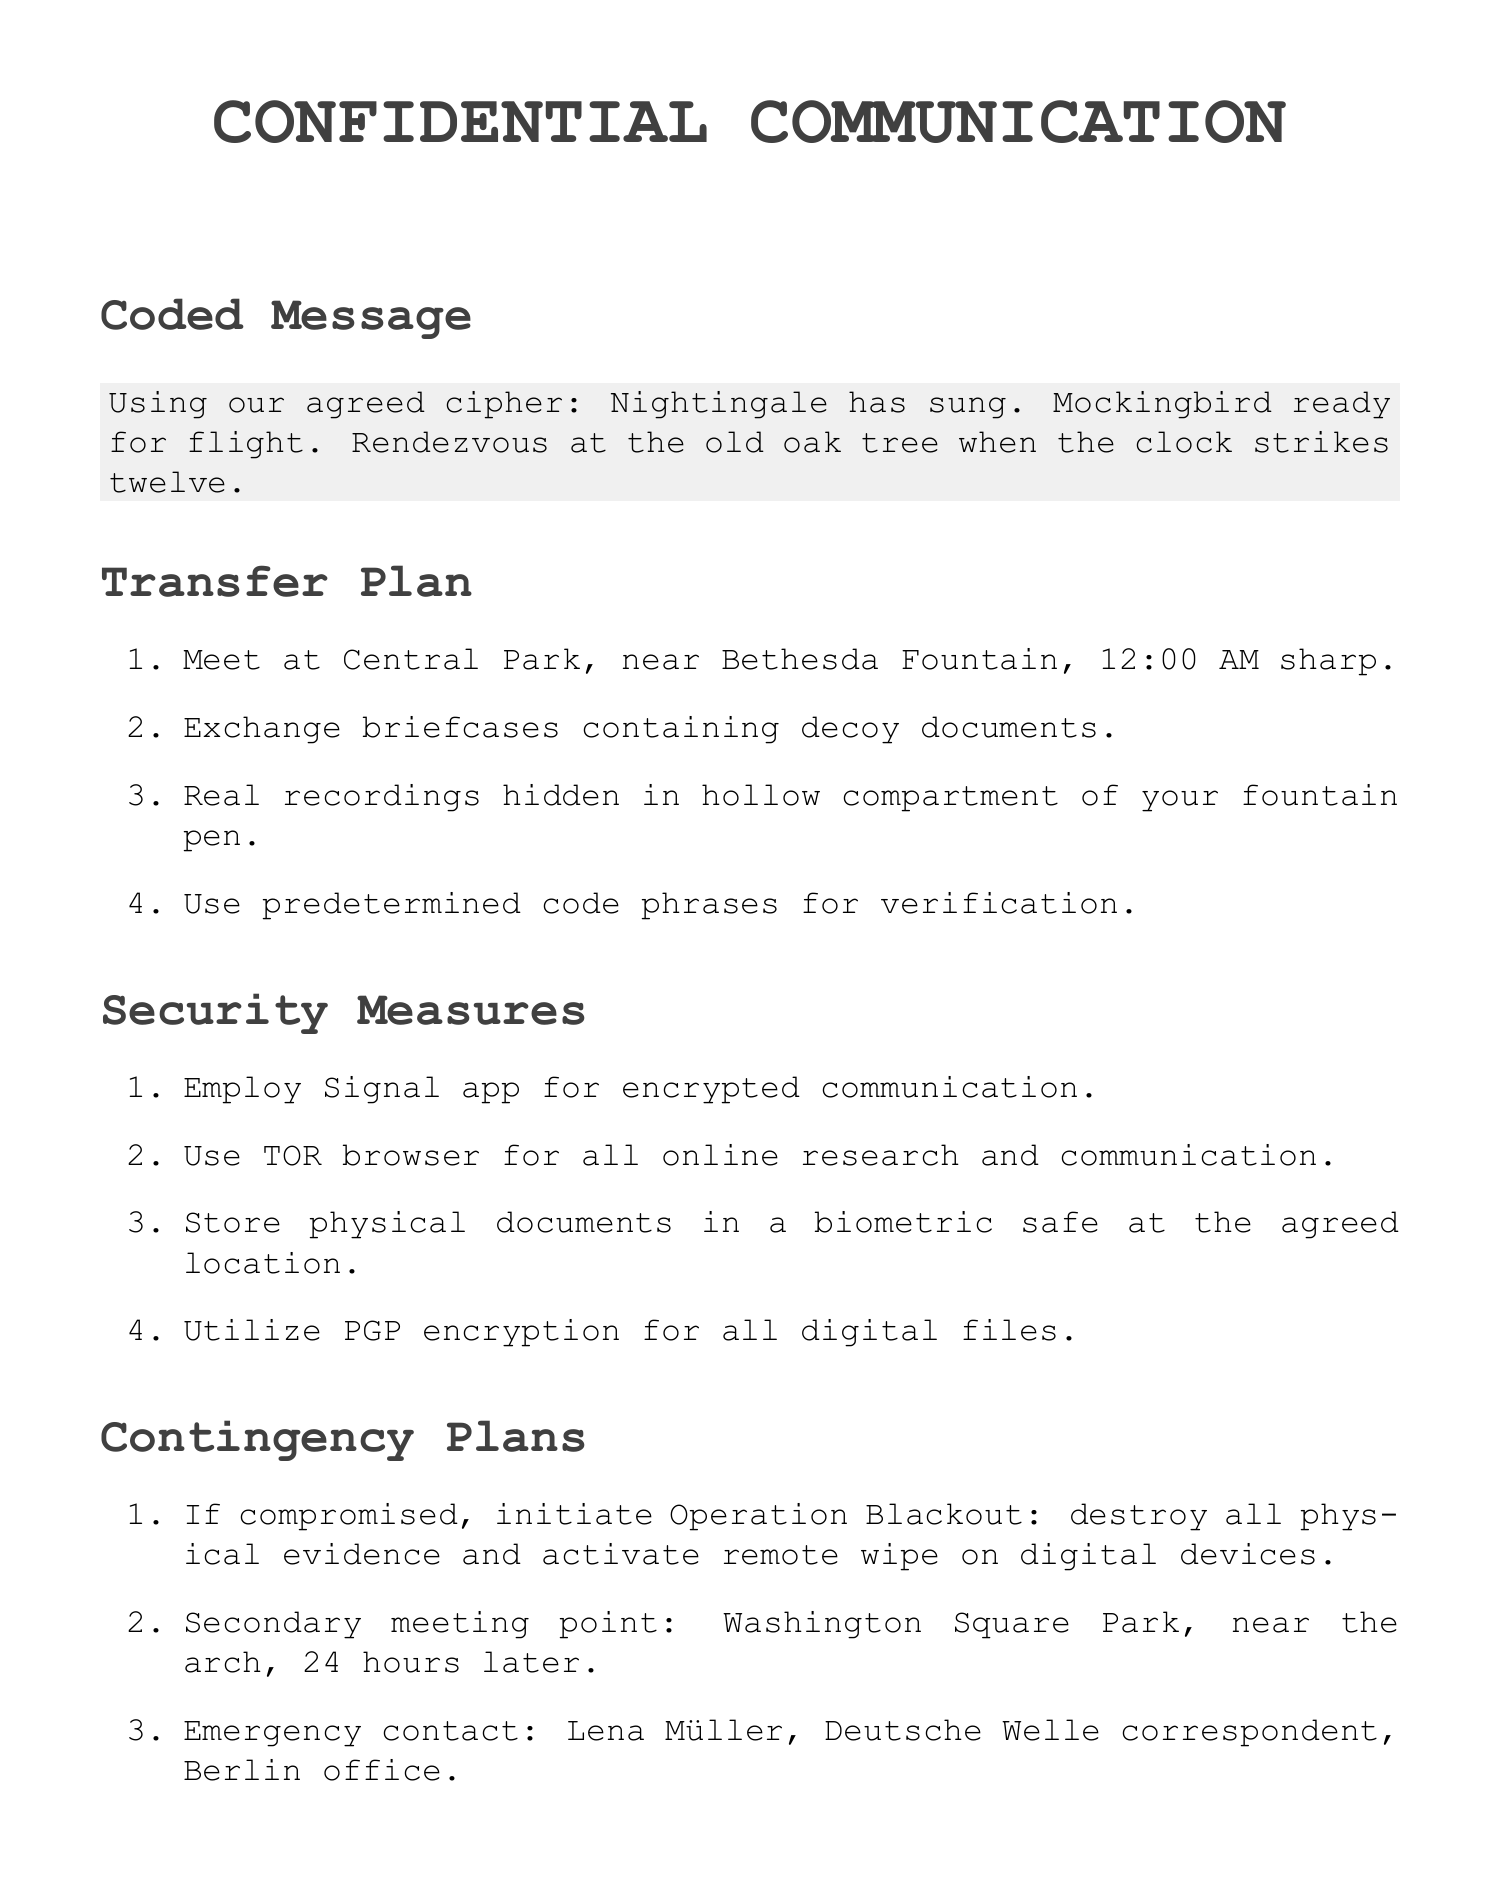What is the codename for the interview subject? The codename is specified in the section detailing the interview subject, which is listed as "Deep Throat II."
Answer: Deep Throat II What time is the rendezvous scheduled for? The meeting time is explicitly mentioned in the transfer plan as the time to meet at the location.
Answer: 12:00 AM What is the primary location for document storage? The primary location is identified in the document storage section as a specific bank.
Answer: First Republic Bank What is the secondary meeting point if the first is compromised? The document outlines a contingency plan which includes a designated secondary meeting point.
Answer: Washington Square Park What encryption method is suggested for digital files? The document states the specific method to use for securing digital files in the security measures section.
Answer: PGP encryption What should be done if compromised? The contingency plans section specifies a particular operation to initiate if they are compromised.
Answer: Operation Blackout Which app is recommended for encrypted communication? The document includes a specific app for communication under the security measures section.
Answer: Signal Who is the emergency contact mentioned in the contingency plans? An emergency contact is provided in the contingency plans, which is listed with name and affiliation.
Answer: Lena Müller 